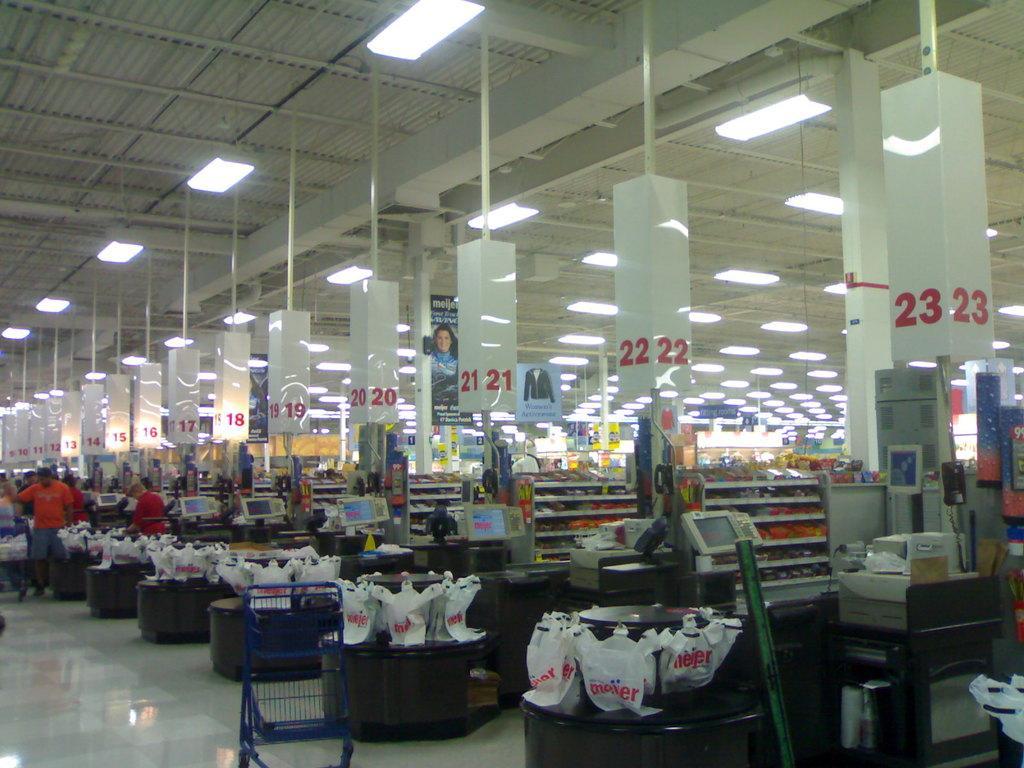In one or two sentences, can you explain what this image depicts? This image is taken indoors. At the top of the image there is a roof and there are many lights. At the bottom of the image there is a floor. On the left side of the image there are a few people standing on the floor. In the middle of the image there are many baskets and packets on the tables. There are many boards with text on them. There are many objects. 